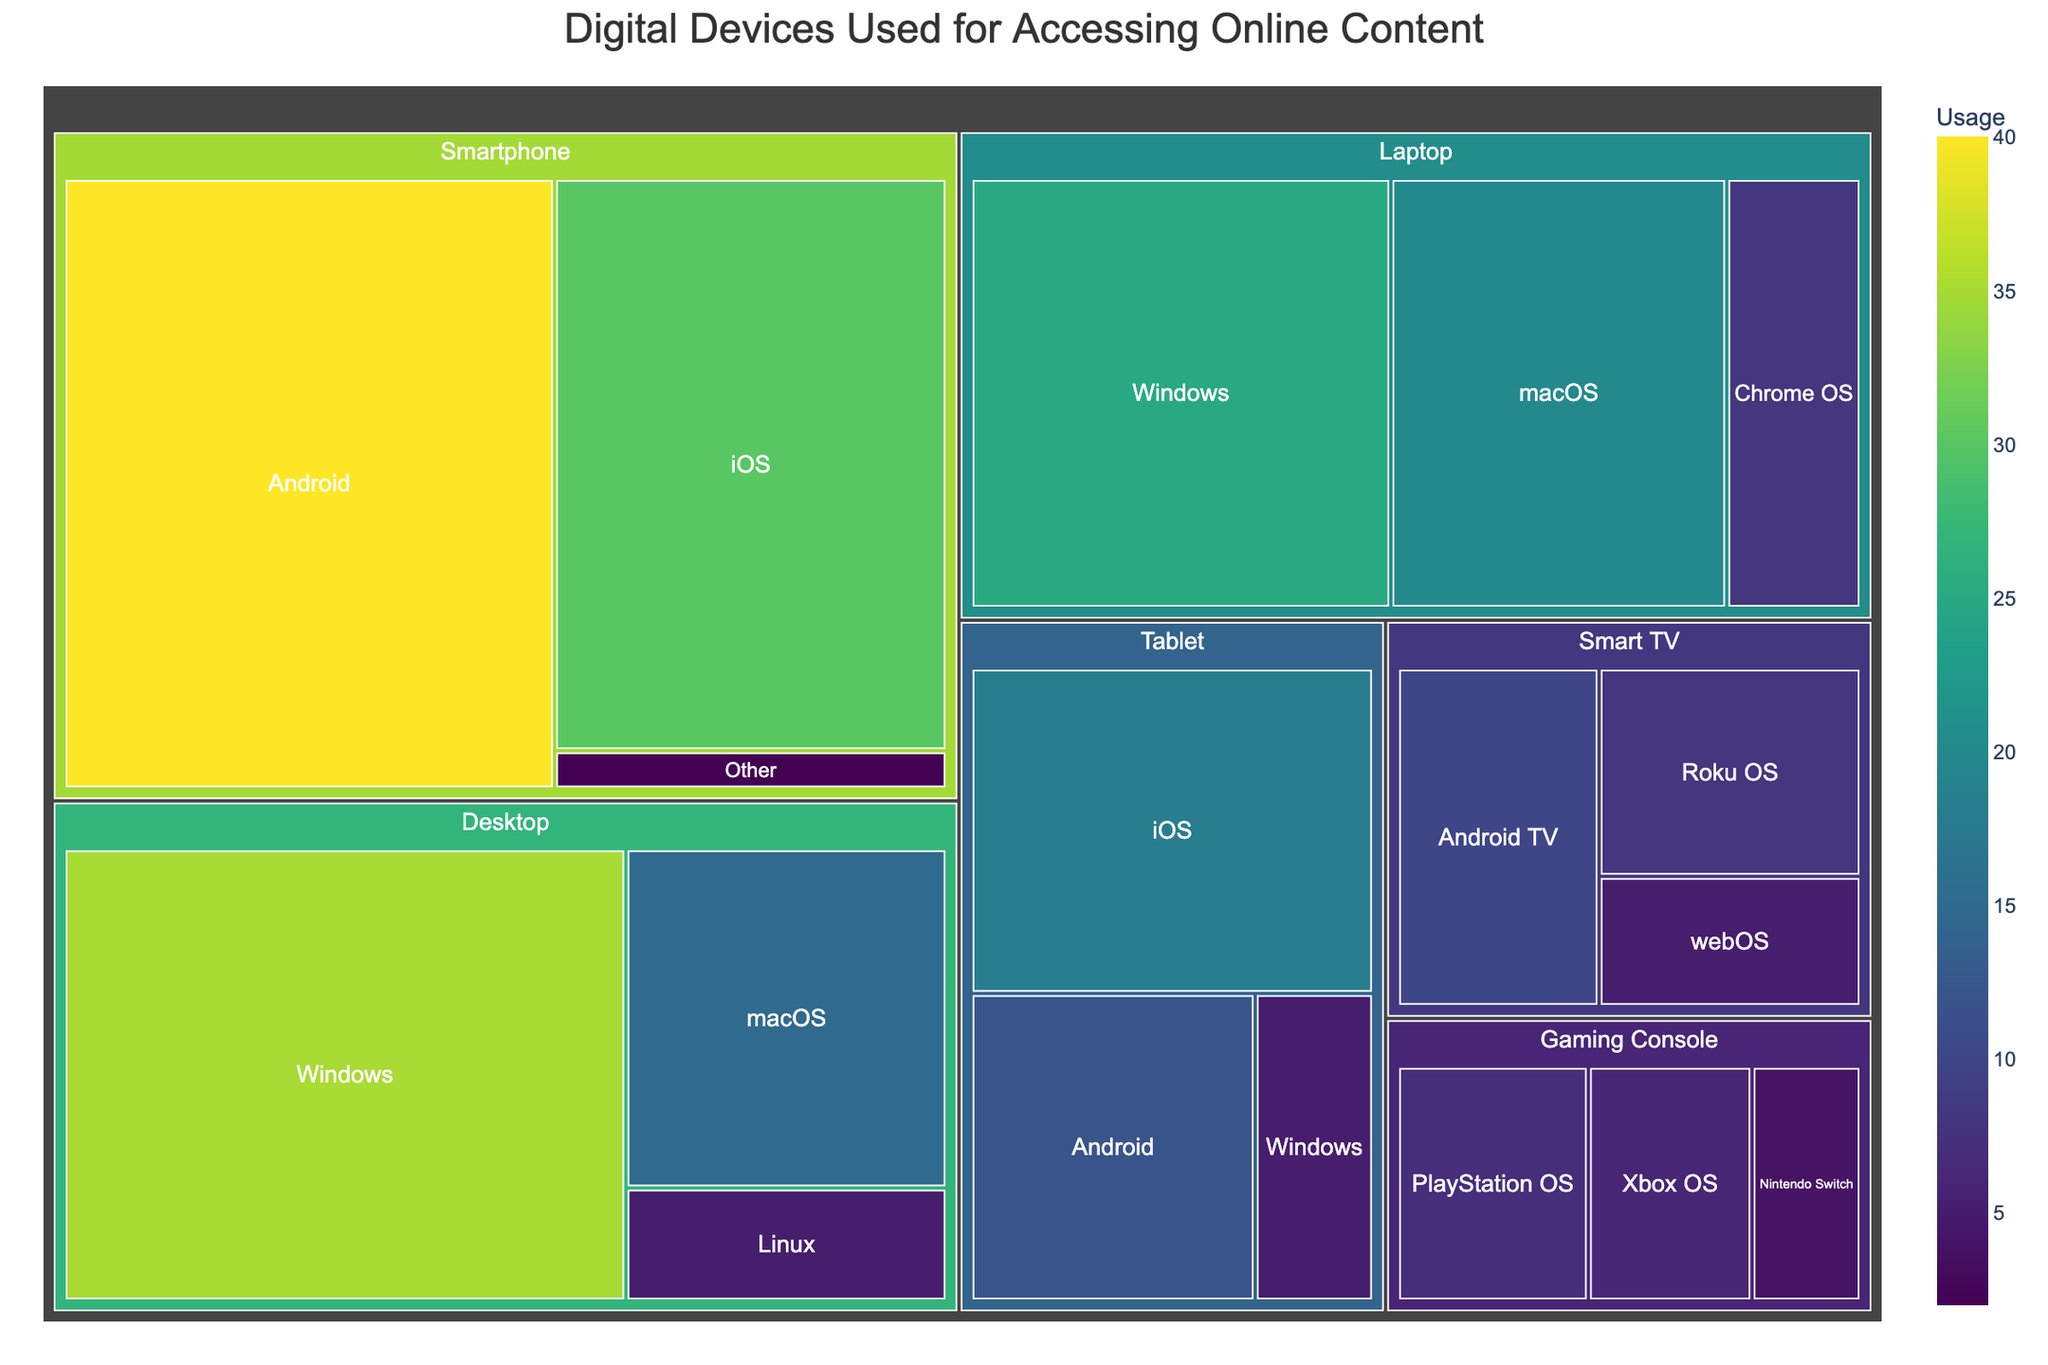What is the title of the plot? The title of the plot is typically found at the top of the figure, styled in larger font. It usually provides a brief description of what the plot represents.
Answer: Digital Devices Used for Accessing Online Content Which digital device has the highest usage for accessing online content? Identify the largest segment in the treemap, as larger segments represent higher values.
Answer: Smartphone (Android) How many categories of digital devices are represented in the treemap? Each unique color-coded and labeled section at the first level of the hierarchy represents a different category. Count these categories.
Answer: Six What is the combined usage value for tablets? Locate the ‘Tablet’ section in the treemap, then sum all subcategories under ‘Tablet’. The values to sum are 18 (iOS) + 12 (Android) + 5 (Windows).
Answer: 35 Which subcategory within the 'Desktop' category has the smallest usage? Within the ‘Desktop’ category, locate the smallest segment in terms of size and number.
Answer: Linux Which has a higher usage value, laptops running Windows or desktops running macOS? Compare the segment sizes for ‘Laptop’ with ‘Windows’ and ‘Desktop’ with ‘macOS’. The numeric values will make it clearer.
Answer: Laptop (Windows) What is the average usage value across all operating systems for 'Smart TV'? Locate the ‘Smart TV’ category and list the values for its subcategories: 10 (Android TV), 8 (Roku OS), and 5 (webOS). Find the average by summing these values and dividing by 3.
Answer: 7.67 How does the number of subcategories in 'Smartphone' compare to those in 'Gaming Console'? Count the number of subcategories (rectangles) under ‘Smartphone’ and ‘Gaming Console’.
Answer: Smartphone has more subcategories (3 vs. 3) What is the total usage value for all digital devices combined? Sum the values of all subcategories. Adding values from each part of the tree: 35+15+5+25+20+8+18+12+5+40+30+2+10+8+5+7+6+4.
Answer: 255 Which category has the least total usage value, and what is that value? Add the values of subcategories within each category and identify the smallest total.
Answer: Gaming Console; 17 